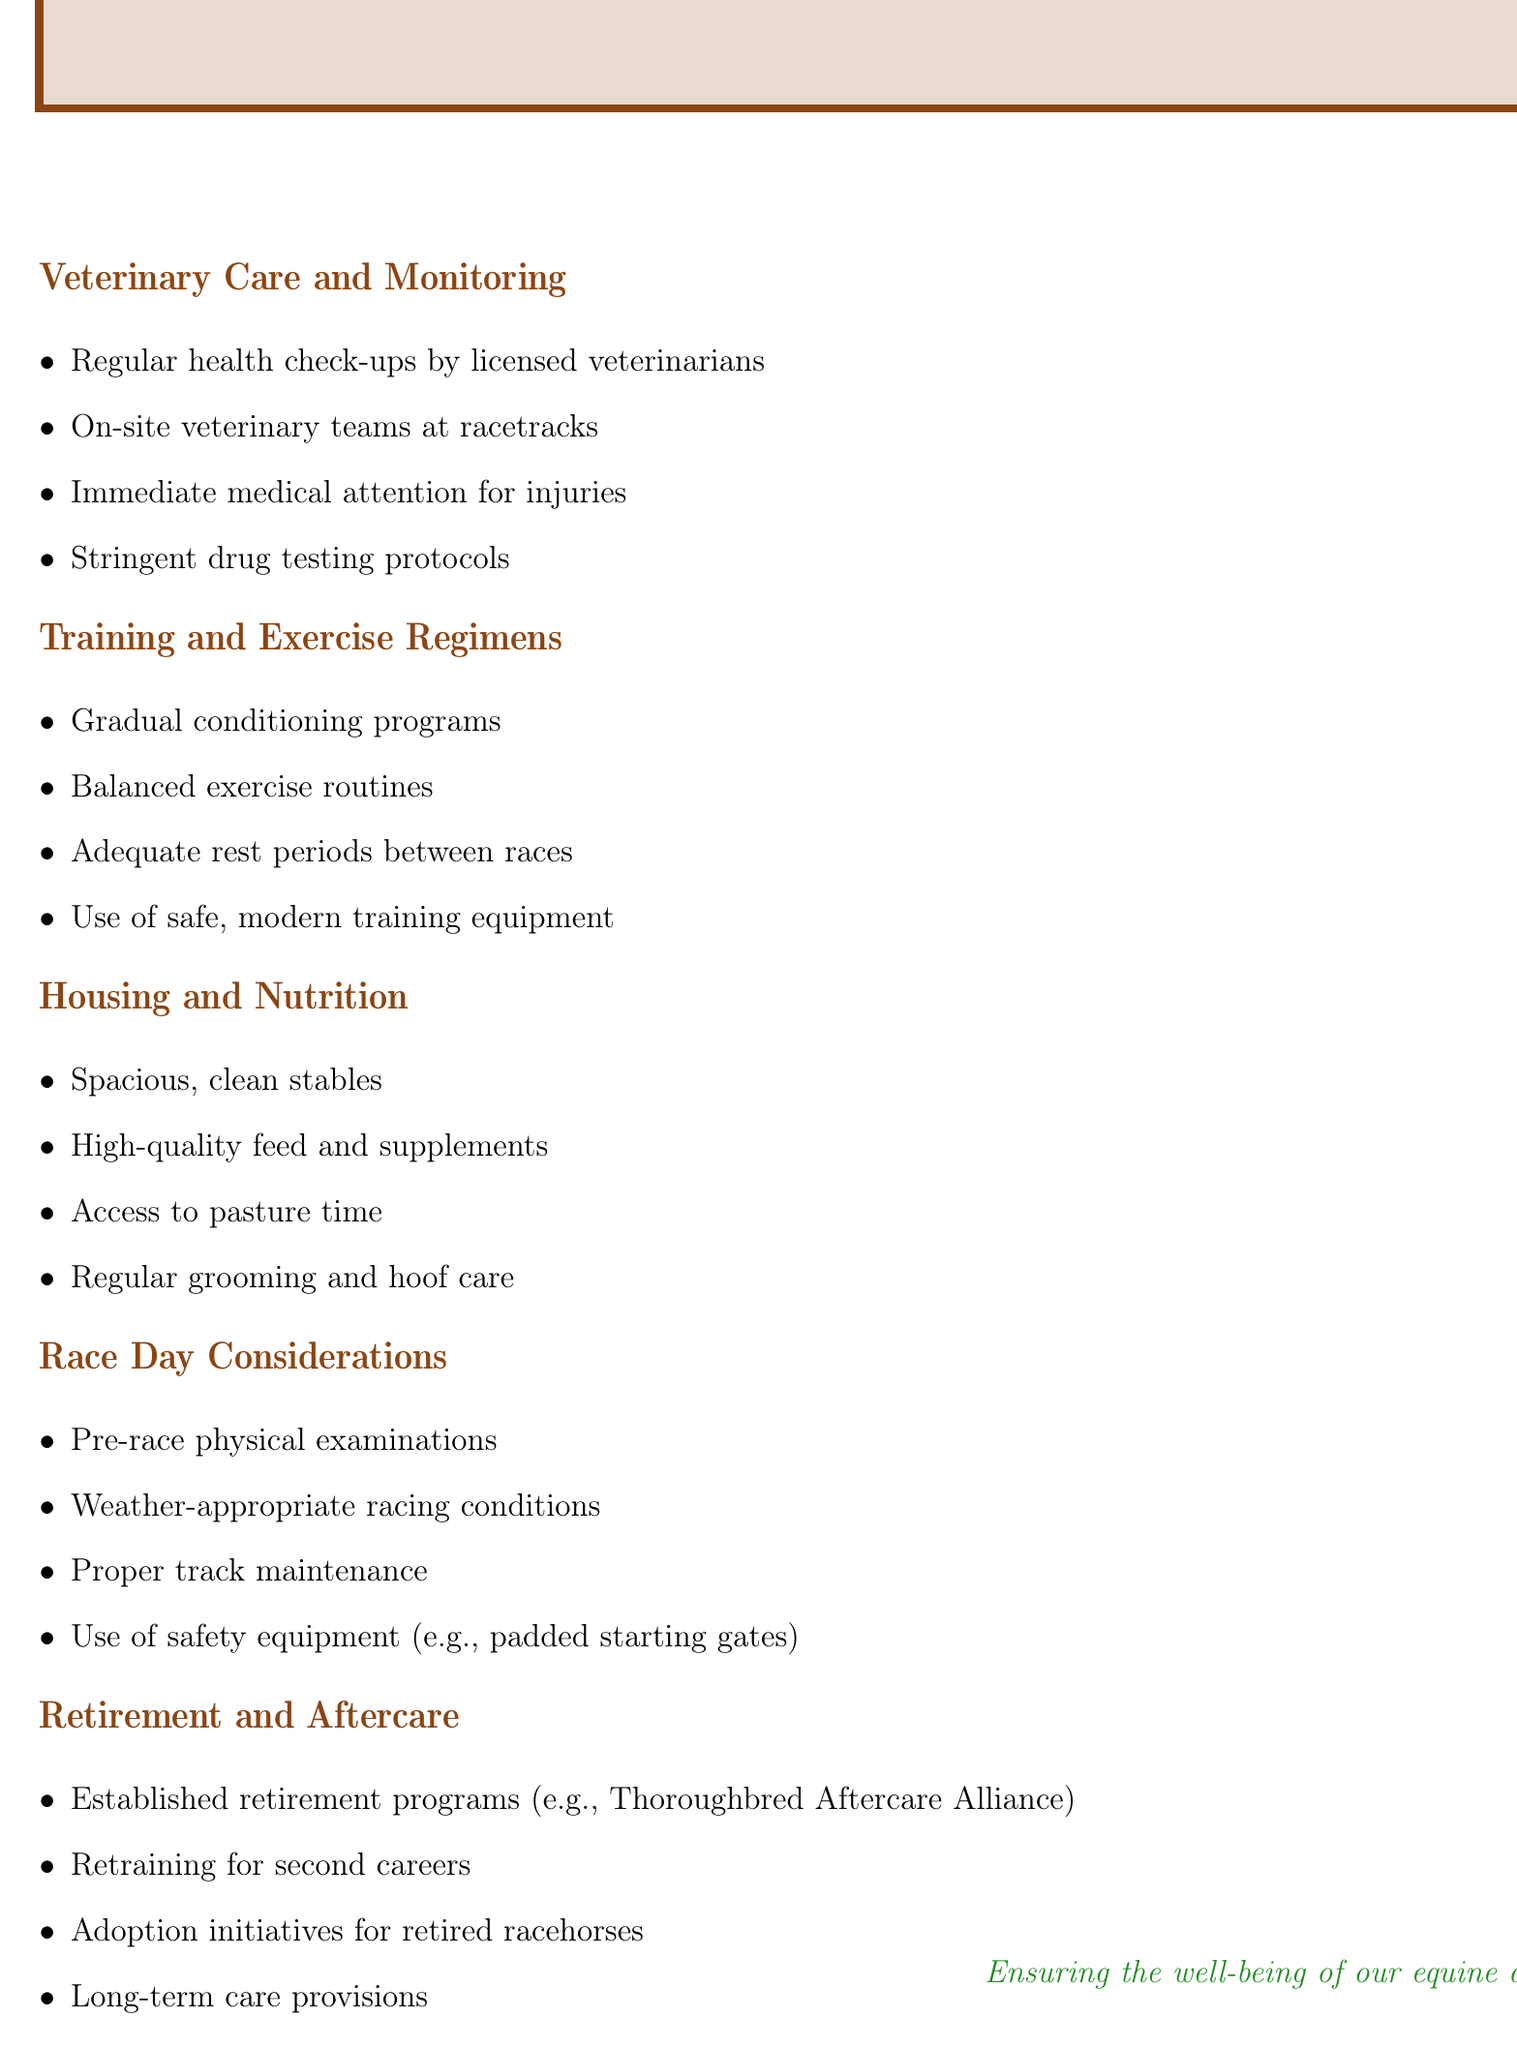What are the veterinary care practices mentioned? The document lists several veterinary care practices, including regular health check-ups and on-site veterinary teams.
Answer: Regular health check-ups by licensed veterinarians, on-site veterinary teams at racetracks, immediate medical attention for injuries, stringent drug testing protocols How many points are listed under Training and Exercise Regimens? The document specifies four key points under this section.
Answer: Four What is one important aspect of housing for racehorses? The document points out that spacious and clean stables are crucial for housing.
Answer: Spacious, clean stables What type of physical examination is conducted on race day? According to the document, cats are subjected to a pre-race physical examination.
Answer: Pre-race physical examinations What does the document say about retirement programs? The document mentions the need for established retirement programs for racehorses.
Answer: Established retirement programs (e.g., Thoroughbred Aftercare Alliance) How is the well-being of equine athletes emphasized in the document? The final statement in the document underscores the commitment to ensuring their well-being.
Answer: Ensuring the well-being of our equine athletes 